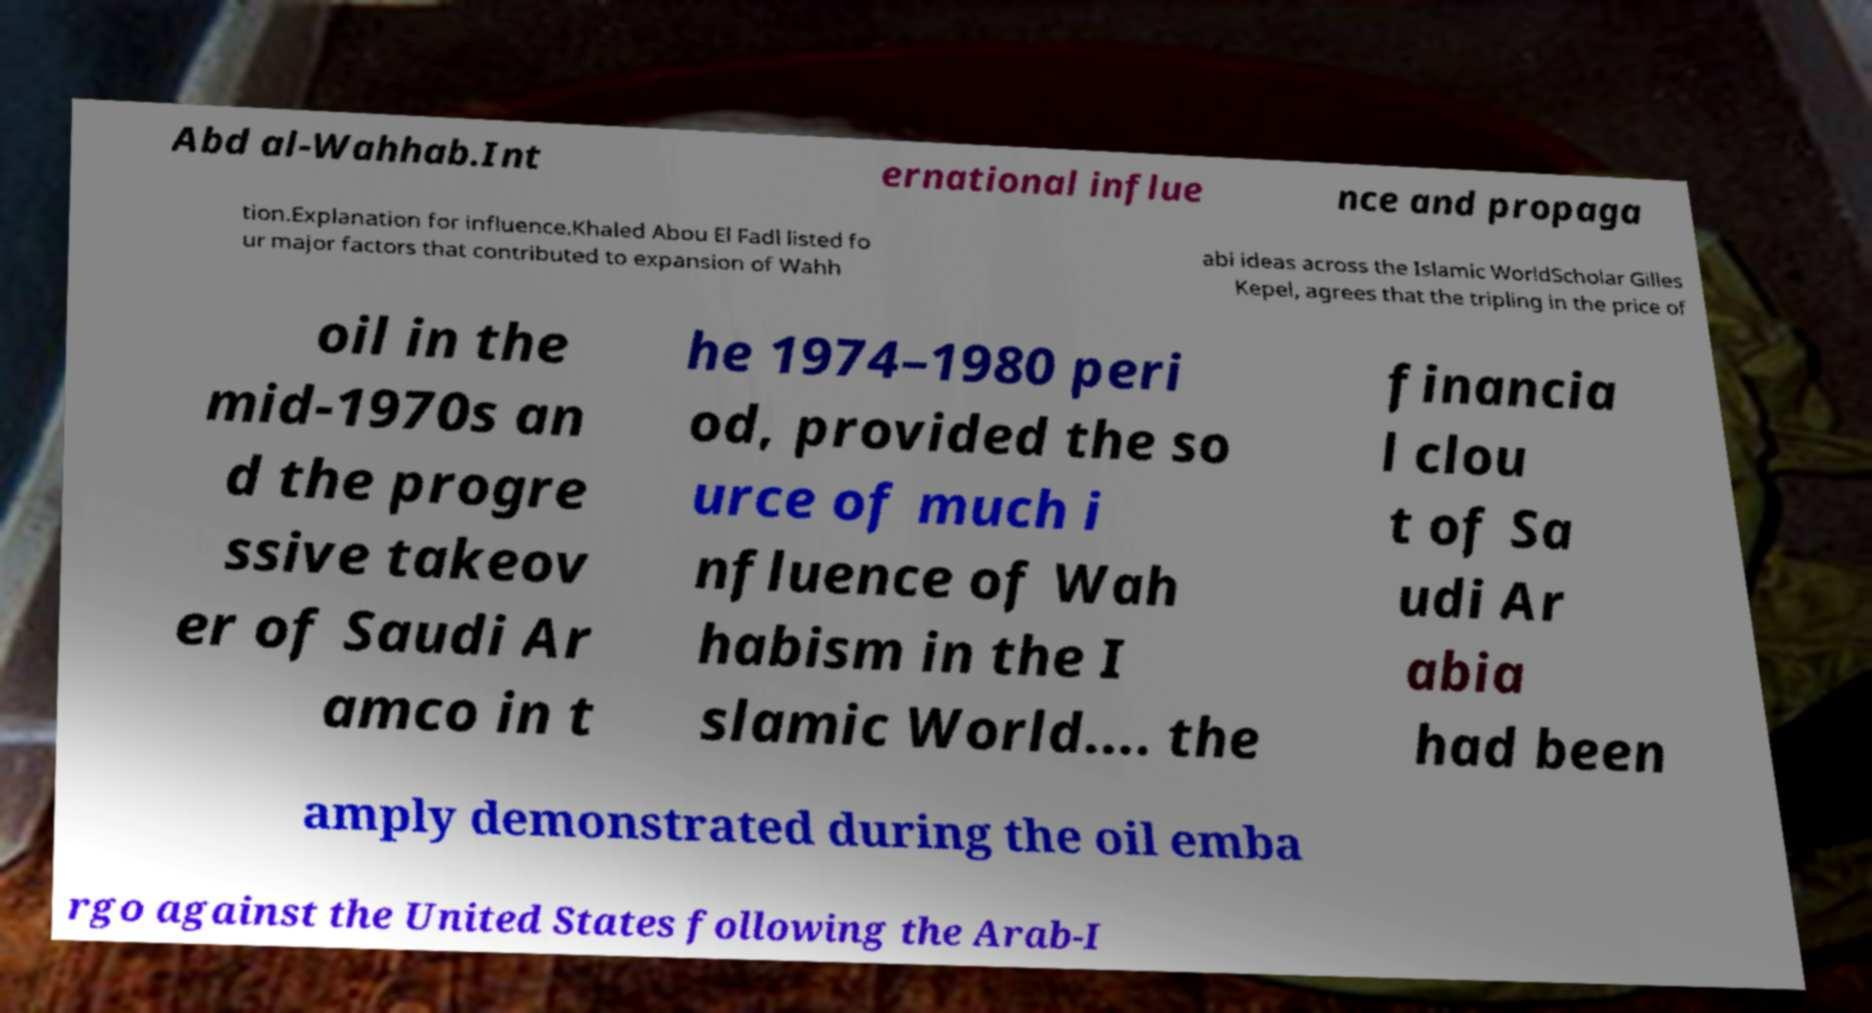I need the written content from this picture converted into text. Can you do that? Abd al-Wahhab.Int ernational influe nce and propaga tion.Explanation for influence.Khaled Abou El Fadl listed fo ur major factors that contributed to expansion of Wahh abi ideas across the Islamic WorldScholar Gilles Kepel, agrees that the tripling in the price of oil in the mid-1970s an d the progre ssive takeov er of Saudi Ar amco in t he 1974–1980 peri od, provided the so urce of much i nfluence of Wah habism in the I slamic World.... the financia l clou t of Sa udi Ar abia had been amply demonstrated during the oil emba rgo against the United States following the Arab-I 